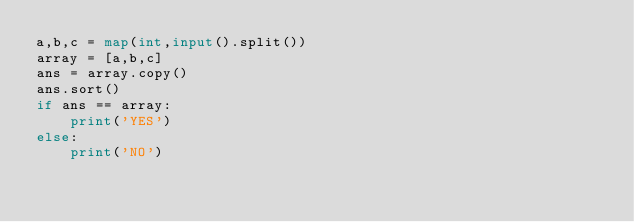Convert code to text. <code><loc_0><loc_0><loc_500><loc_500><_Python_>a,b,c = map(int,input().split())
array = [a,b,c]
ans = array.copy()
ans.sort()
if ans == array:
    print('YES')
else:
    print('NO')</code> 